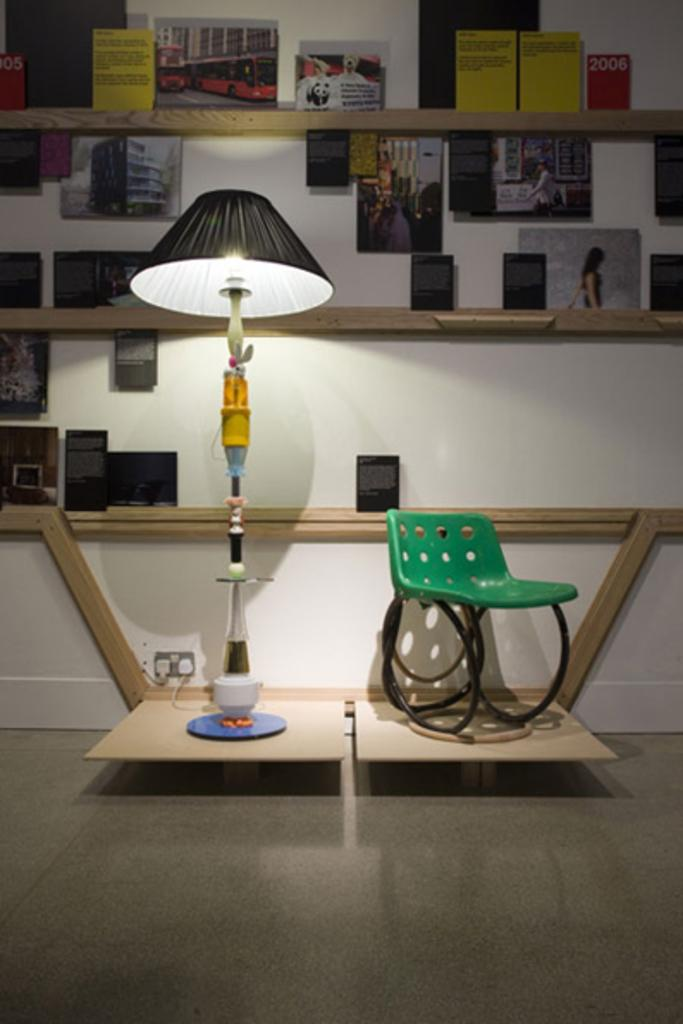What type of lighting fixture is present in the image? There is a lamp in the image. What type of furniture is present in the image? There is a chair in the image. What device is used for controlling electrical appliances in the image? There is a switch board in the image. What type of storage is present in the image? There are shelves in the image. What is the color of the wall in the image? The wall in the image is white. What type of decorative items are present in the image? There are photo frames in the image. Where is the tub located in the image? There is no tub present in the image. What type of coach is visible in the image? There is no coach present in the image. 